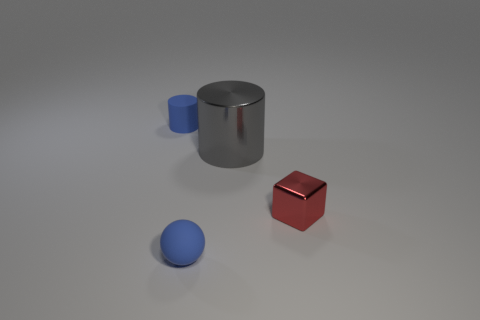Add 2 tiny green shiny things. How many objects exist? 6 Subtract all blocks. How many objects are left? 3 Add 4 small cyan shiny blocks. How many small cyan shiny blocks exist? 4 Subtract 0 gray balls. How many objects are left? 4 Subtract all red shiny blocks. Subtract all small blue things. How many objects are left? 1 Add 3 matte cylinders. How many matte cylinders are left? 4 